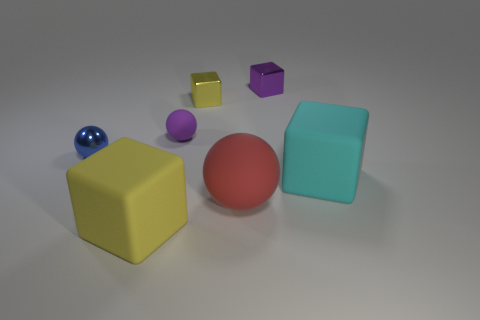Are there any other small things of the same color as the tiny matte object?
Make the answer very short. Yes. What size is the metal object that is the same color as the tiny matte ball?
Offer a terse response. Small. There is a cube that is behind the large cyan thing and on the left side of the red thing; what is its color?
Offer a very short reply. Yellow. Are the big block that is to the left of the tiny yellow thing and the red thing made of the same material?
Your response must be concise. Yes. Does the small rubber thing have the same color as the metallic cube on the right side of the red rubber object?
Provide a succinct answer. Yes. Are there any large rubber things on the left side of the small yellow metallic thing?
Your answer should be compact. Yes. There is a matte cube to the left of the tiny yellow cube; is its size the same as the blue shiny thing that is on the left side of the red matte ball?
Your answer should be compact. No. Is there a metal block that has the same size as the blue metal object?
Make the answer very short. Yes. There is a metallic object in front of the yellow metallic cube; does it have the same shape as the purple metal thing?
Offer a terse response. No. There is a ball on the right side of the small yellow metal thing; what is it made of?
Give a very brief answer. Rubber. 